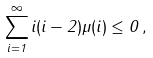Convert formula to latex. <formula><loc_0><loc_0><loc_500><loc_500>\sum _ { i = 1 } ^ { \infty } i ( i - 2 ) \mu ( i ) \leq 0 \, ,</formula> 